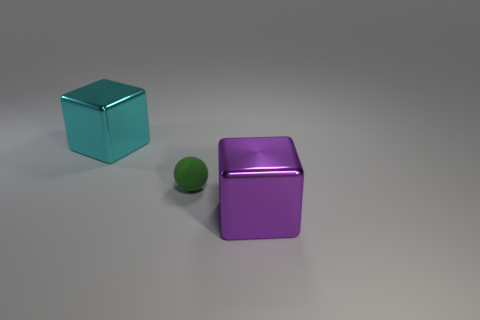Is the size of the cyan metal thing the same as the purple cube?
Offer a very short reply. Yes. How many matte things are green cylinders or small balls?
Your response must be concise. 1. There is a block that is the same size as the purple object; what material is it?
Make the answer very short. Metal. How many other objects are the same material as the cyan thing?
Your answer should be compact. 1. Is the number of balls right of the purple metallic block less than the number of big gray things?
Your answer should be compact. No. Is the shape of the green thing the same as the large purple object?
Give a very brief answer. No. What size is the metallic thing that is behind the metallic thing that is right of the shiny block behind the green matte object?
Provide a short and direct response. Large. What material is the other thing that is the same shape as the large cyan object?
Provide a succinct answer. Metal. Is there any other thing that has the same size as the purple object?
Your response must be concise. Yes. There is a cube that is on the right side of the metallic block that is behind the small thing; what size is it?
Offer a terse response. Large. 